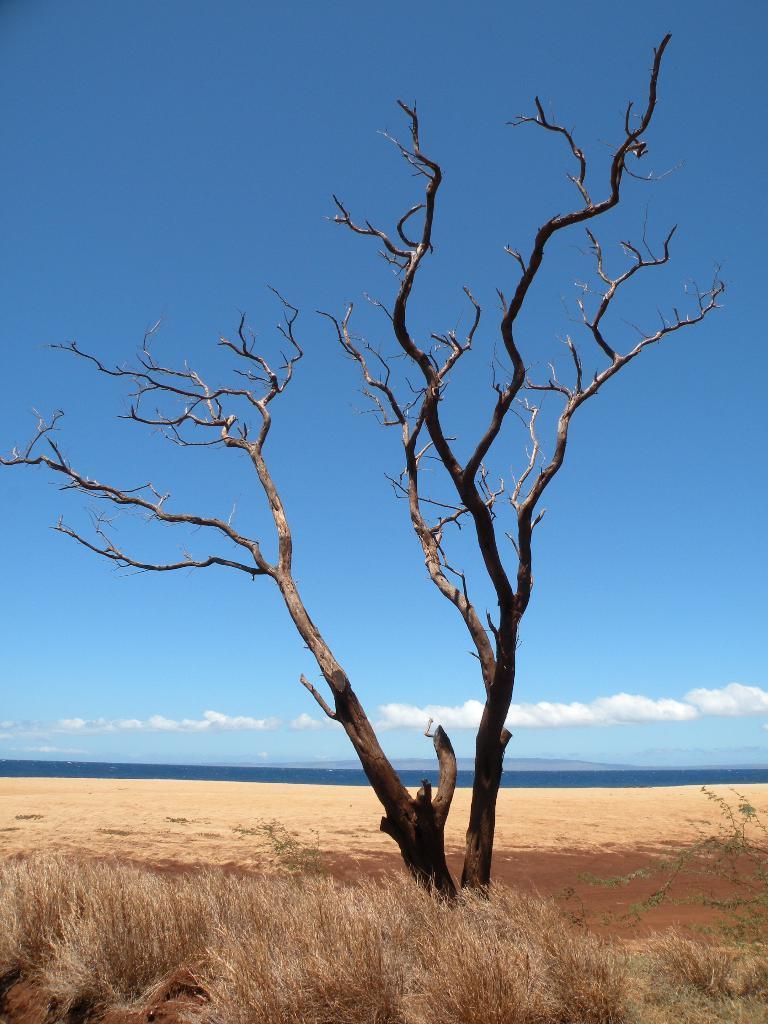In one or two sentences, can you explain what this image depicts? In this image I can see a dried tree and I can also see dried grass and sky is in blue and white color. 